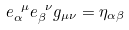Convert formula to latex. <formula><loc_0><loc_0><loc_500><loc_500>e _ { \alpha } ^ { \ \mu } e _ { \beta } ^ { \ \nu } g _ { \mu \nu } = \eta _ { \alpha \beta }</formula> 